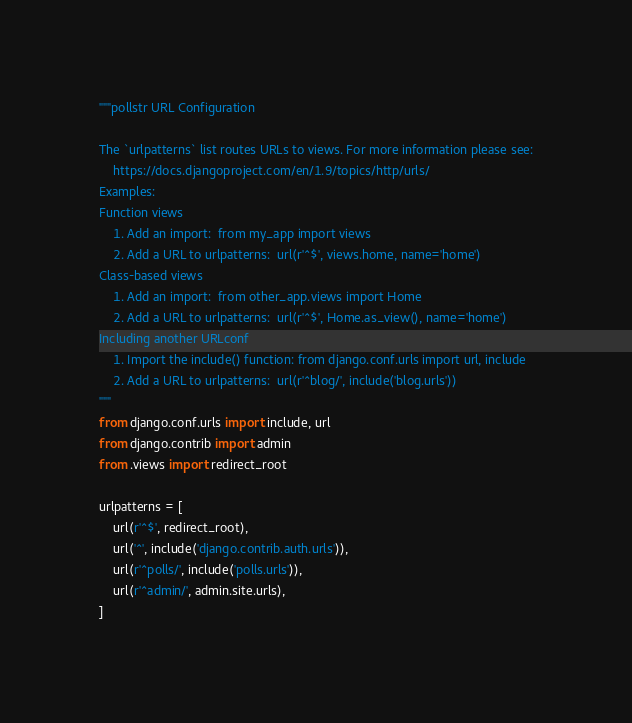Convert code to text. <code><loc_0><loc_0><loc_500><loc_500><_Python_>"""pollstr URL Configuration

The `urlpatterns` list routes URLs to views. For more information please see:
    https://docs.djangoproject.com/en/1.9/topics/http/urls/
Examples:
Function views
    1. Add an import:  from my_app import views
    2. Add a URL to urlpatterns:  url(r'^$', views.home, name='home')
Class-based views
    1. Add an import:  from other_app.views import Home
    2. Add a URL to urlpatterns:  url(r'^$', Home.as_view(), name='home')
Including another URLconf
    1. Import the include() function: from django.conf.urls import url, include
    2. Add a URL to urlpatterns:  url(r'^blog/', include('blog.urls'))
"""
from django.conf.urls import include, url
from django.contrib import admin
from .views import redirect_root

urlpatterns = [
    url(r'^$', redirect_root),
    url('^', include('django.contrib.auth.urls')),
    url(r'^polls/', include('polls.urls')),
    url(r'^admin/', admin.site.urls),
]
</code> 